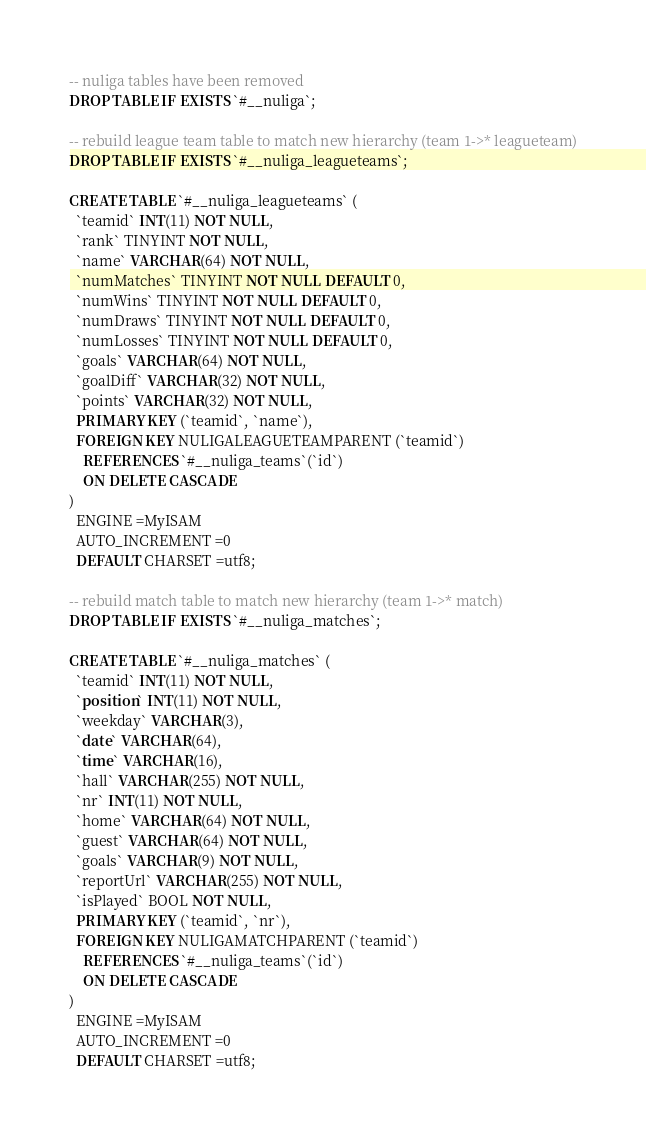<code> <loc_0><loc_0><loc_500><loc_500><_SQL_>-- nuliga tables have been removed
DROP TABLE IF EXISTS `#__nuliga`;

-- rebuild league team table to match new hierarchy (team 1->* leagueteam)
DROP TABLE IF EXISTS `#__nuliga_leagueteams`;

CREATE TABLE `#__nuliga_leagueteams` (
  `teamid` INT(11) NOT NULL,
  `rank` TINYINT NOT NULL,
  `name` VARCHAR(64) NOT NULL,
  `numMatches` TINYINT NOT NULL DEFAULT 0,
  `numWins` TINYINT NOT NULL DEFAULT 0,
  `numDraws` TINYINT NOT NULL DEFAULT 0,
  `numLosses` TINYINT NOT NULL DEFAULT 0,
  `goals` VARCHAR(64) NOT NULL,
  `goalDiff` VARCHAR(32) NOT NULL,
  `points` VARCHAR(32) NOT NULL,
  PRIMARY KEY (`teamid`, `name`),
  FOREIGN KEY NULIGALEAGUETEAMPARENT (`teamid`)
    REFERENCES `#__nuliga_teams`(`id`)
    ON DELETE CASCADE
)
  ENGINE =MyISAM
  AUTO_INCREMENT =0
  DEFAULT CHARSET =utf8;

-- rebuild match table to match new hierarchy (team 1->* match)
DROP TABLE IF EXISTS `#__nuliga_matches`;

CREATE TABLE `#__nuliga_matches` (
  `teamid` INT(11) NOT NULL,
  `position` INT(11) NOT NULL,
  `weekday` VARCHAR(3),
  `date` VARCHAR(64),
  `time` VARCHAR(16),
  `hall` VARCHAR(255) NOT NULL,
  `nr` INT(11) NOT NULL,
  `home` VARCHAR(64) NOT NULL,
  `guest` VARCHAR(64) NOT NULL,
  `goals` VARCHAR(9) NOT NULL,
  `reportUrl` VARCHAR(255) NOT NULL,
  `isPlayed` BOOL NOT NULL,
  PRIMARY KEY (`teamid`, `nr`),
  FOREIGN KEY NULIGAMATCHPARENT (`teamid`)
    REFERENCES `#__nuliga_teams`(`id`)
    ON DELETE CASCADE
)
  ENGINE =MyISAM
  AUTO_INCREMENT =0
  DEFAULT CHARSET =utf8;
</code> 